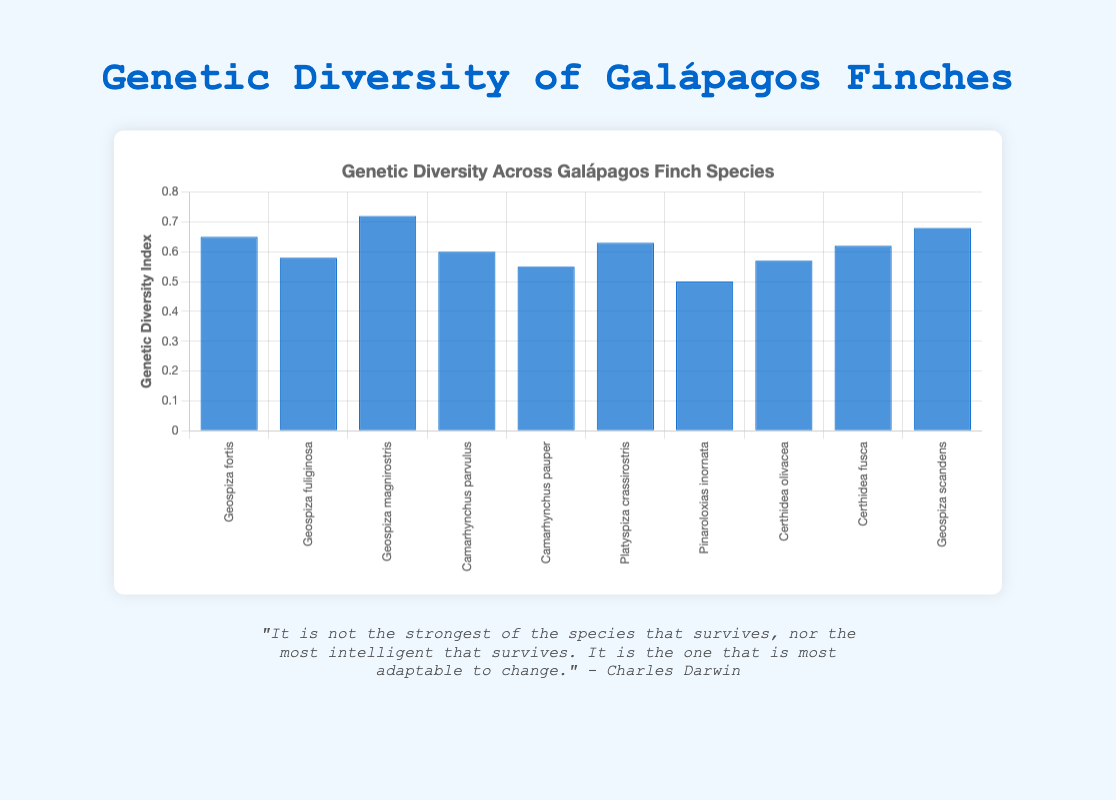What's the species with the highest Genetic Diversity Index? The bar corresponding to "Geospiza magnirostris" is the tallest in the chart, indicating it has the highest value.
Answer: Geospiza magnirostris How does Geospiza scandens compare to Geospiza fortis in terms of genetic diversity? The bar for "Geospiza scandens" is taller than the bar for "Geospiza fortis", showing that Geospiza scandens has a higher Genetic Diversity Index.
Answer: Geospiza scandens has higher genetic diversity What is the median Genetic Diversity Index value among all the species? To find the median, first list the values in order: 0.50, 0.55, 0.57, 0.58, 0.60, 0.62, 0.63, 0.65, 0.68, 0.72. The median is the middle value of the ordered list, which is 0.60 and 0.62, thus the median is (0.60 + 0.62) / 2 = 0.61
Answer: 0.61 How many species have a Genetic Diversity Index below 0.60? Counting the bars lower than the 0.60 line, we see the values for "Pinaroloxias inornata", "Camarhynchus pauper", "Certhidea olivacea", and "Geospiza fuliginosa" are below 0.60.
Answer: 4 species Which two species have the closest Genetic Diversity Index values? "Geospiza fortis" (0.65) and "Geospiza scandens" (0.68) are visually close, but "Camarhynchus pauper" (0.55) and "Certhidea olivacea" (0.57) have a smaller absolute difference.
Answer: Camarhynchus pauper and Certhidea olivacea What is the range of Genetic Diversity Index values in this dataset? The range is calculated as the difference between the highest (0.72) and the lowest (0.50) values. So, the range is 0.72 - 0.50 = 0.22.
Answer: 0.22 Which species have a Genetic Diversity Index above 0.65? From the chart, the bars taller than the 0.65 line belong to "Geospiza magnirostris" (0.72) and "Geospiza scandens" (0.68).
Answer: Geospiza magnirostris and Geospiza scandens How does the Genetic Diversity Index of Platyspiza crassirostris compare to the average index of all species? Calculate the average by summing all values (0.65 + 0.58 + 0.72 + 0.60 + 0.55 + 0.63 + 0.50 + 0.57 + 0.62 + 0.68 = 6.10) and dividing by the number of species (10), which gives an average of 0.61. Platyspiza crassirostris (0.63) is higher than this average.
Answer: Higher than average 